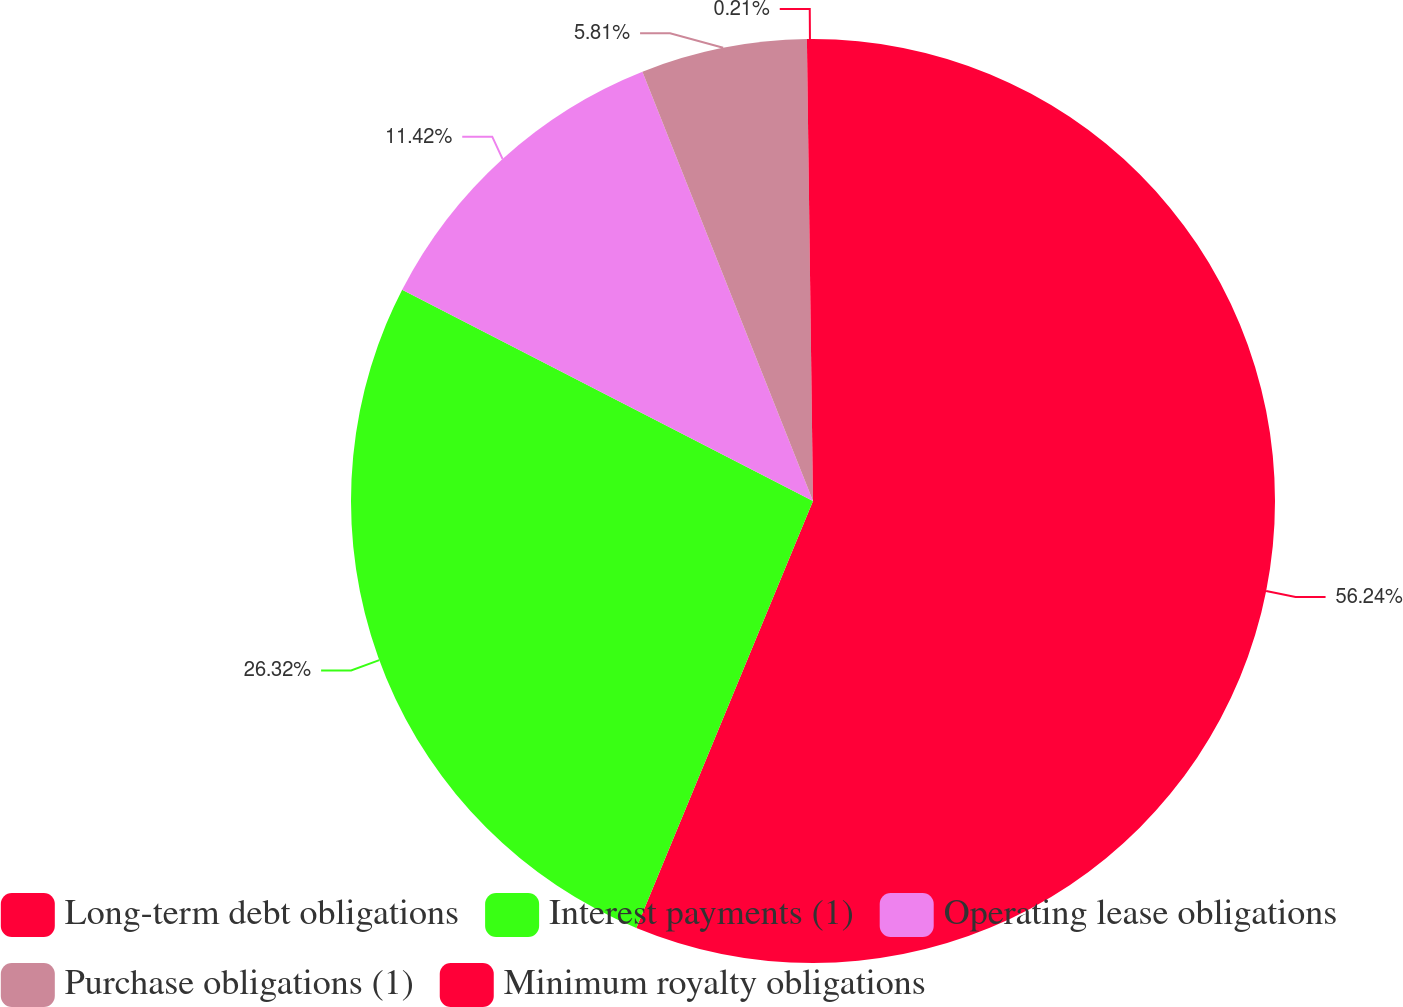Convert chart. <chart><loc_0><loc_0><loc_500><loc_500><pie_chart><fcel>Long-term debt obligations<fcel>Interest payments (1)<fcel>Operating lease obligations<fcel>Purchase obligations (1)<fcel>Minimum royalty obligations<nl><fcel>56.25%<fcel>26.32%<fcel>11.42%<fcel>5.81%<fcel>0.21%<nl></chart> 